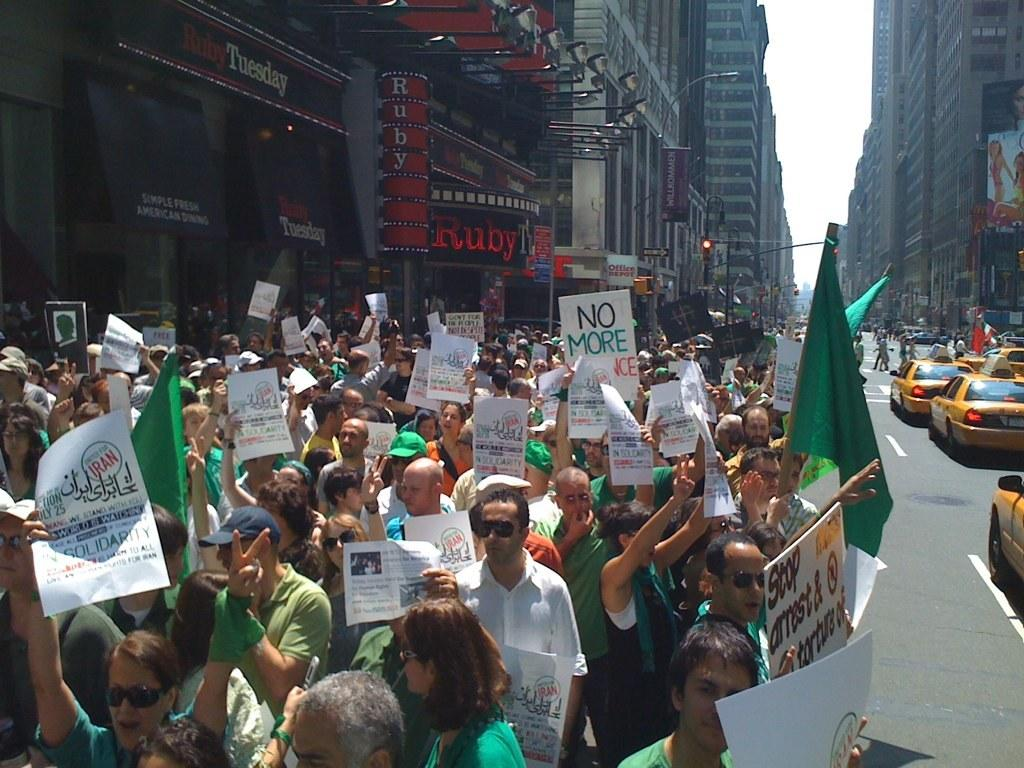<image>
Present a compact description of the photo's key features. Protesters holding signs which say "No more" and carrying green flags. 